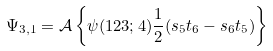Convert formula to latex. <formula><loc_0><loc_0><loc_500><loc_500>\Psi _ { 3 , 1 } = \mathcal { A } \left \{ \psi ( 1 2 3 ; 4 ) \frac { 1 } { 2 } ( s _ { 5 } t _ { 6 } - s _ { 6 } t _ { 5 } ) \right \}</formula> 